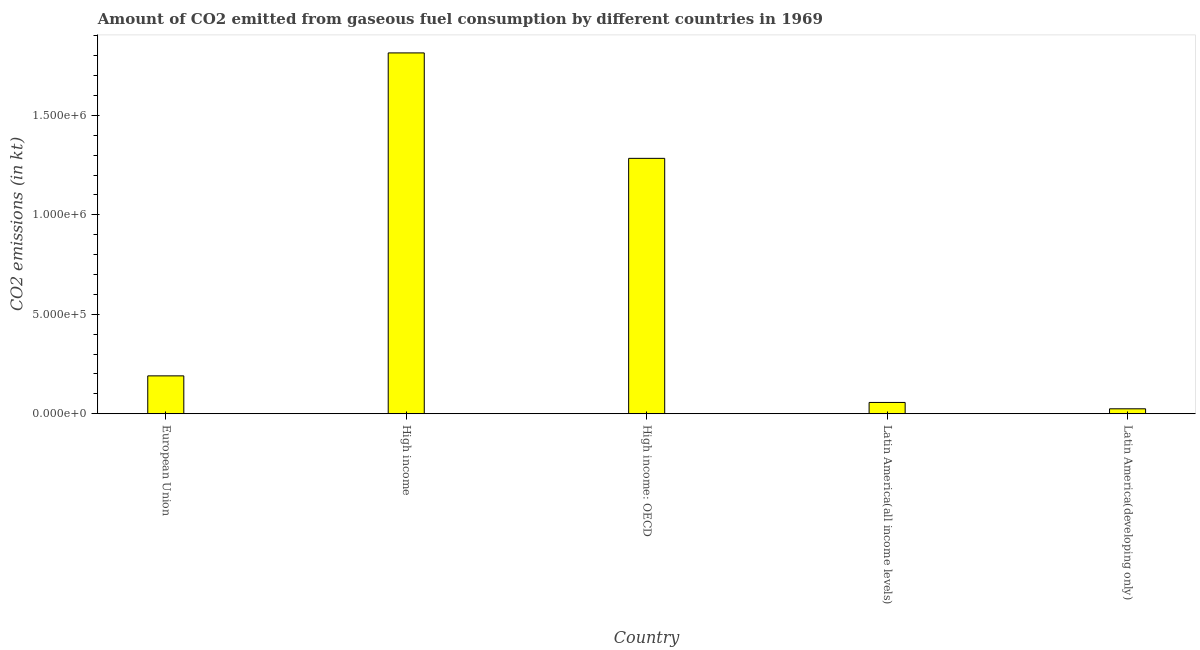What is the title of the graph?
Make the answer very short. Amount of CO2 emitted from gaseous fuel consumption by different countries in 1969. What is the label or title of the Y-axis?
Your response must be concise. CO2 emissions (in kt). What is the co2 emissions from gaseous fuel consumption in Latin America(all income levels)?
Keep it short and to the point. 5.68e+04. Across all countries, what is the maximum co2 emissions from gaseous fuel consumption?
Give a very brief answer. 1.81e+06. Across all countries, what is the minimum co2 emissions from gaseous fuel consumption?
Your response must be concise. 2.48e+04. In which country was the co2 emissions from gaseous fuel consumption maximum?
Ensure brevity in your answer.  High income. In which country was the co2 emissions from gaseous fuel consumption minimum?
Give a very brief answer. Latin America(developing only). What is the sum of the co2 emissions from gaseous fuel consumption?
Provide a short and direct response. 3.37e+06. What is the difference between the co2 emissions from gaseous fuel consumption in Latin America(all income levels) and Latin America(developing only)?
Make the answer very short. 3.20e+04. What is the average co2 emissions from gaseous fuel consumption per country?
Ensure brevity in your answer.  6.74e+05. What is the median co2 emissions from gaseous fuel consumption?
Your answer should be very brief. 1.90e+05. In how many countries, is the co2 emissions from gaseous fuel consumption greater than 1400000 kt?
Your answer should be compact. 1. What is the ratio of the co2 emissions from gaseous fuel consumption in European Union to that in Latin America(developing only)?
Your response must be concise. 7.68. Is the difference between the co2 emissions from gaseous fuel consumption in High income and Latin America(developing only) greater than the difference between any two countries?
Provide a succinct answer. Yes. What is the difference between the highest and the second highest co2 emissions from gaseous fuel consumption?
Make the answer very short. 5.30e+05. Is the sum of the co2 emissions from gaseous fuel consumption in European Union and High income: OECD greater than the maximum co2 emissions from gaseous fuel consumption across all countries?
Make the answer very short. No. What is the difference between the highest and the lowest co2 emissions from gaseous fuel consumption?
Provide a short and direct response. 1.79e+06. In how many countries, is the co2 emissions from gaseous fuel consumption greater than the average co2 emissions from gaseous fuel consumption taken over all countries?
Your answer should be compact. 2. How many bars are there?
Keep it short and to the point. 5. Are all the bars in the graph horizontal?
Your answer should be compact. No. Are the values on the major ticks of Y-axis written in scientific E-notation?
Provide a short and direct response. Yes. What is the CO2 emissions (in kt) in European Union?
Offer a terse response. 1.90e+05. What is the CO2 emissions (in kt) in High income?
Ensure brevity in your answer.  1.81e+06. What is the CO2 emissions (in kt) of High income: OECD?
Provide a short and direct response. 1.28e+06. What is the CO2 emissions (in kt) in Latin America(all income levels)?
Your answer should be compact. 5.68e+04. What is the CO2 emissions (in kt) of Latin America(developing only)?
Make the answer very short. 2.48e+04. What is the difference between the CO2 emissions (in kt) in European Union and High income?
Provide a succinct answer. -1.62e+06. What is the difference between the CO2 emissions (in kt) in European Union and High income: OECD?
Offer a terse response. -1.09e+06. What is the difference between the CO2 emissions (in kt) in European Union and Latin America(all income levels)?
Offer a very short reply. 1.34e+05. What is the difference between the CO2 emissions (in kt) in European Union and Latin America(developing only)?
Your response must be concise. 1.66e+05. What is the difference between the CO2 emissions (in kt) in High income and High income: OECD?
Your answer should be very brief. 5.30e+05. What is the difference between the CO2 emissions (in kt) in High income and Latin America(all income levels)?
Your answer should be very brief. 1.76e+06. What is the difference between the CO2 emissions (in kt) in High income and Latin America(developing only)?
Give a very brief answer. 1.79e+06. What is the difference between the CO2 emissions (in kt) in High income: OECD and Latin America(all income levels)?
Offer a very short reply. 1.23e+06. What is the difference between the CO2 emissions (in kt) in High income: OECD and Latin America(developing only)?
Provide a succinct answer. 1.26e+06. What is the difference between the CO2 emissions (in kt) in Latin America(all income levels) and Latin America(developing only)?
Make the answer very short. 3.20e+04. What is the ratio of the CO2 emissions (in kt) in European Union to that in High income?
Your answer should be compact. 0.1. What is the ratio of the CO2 emissions (in kt) in European Union to that in High income: OECD?
Your response must be concise. 0.15. What is the ratio of the CO2 emissions (in kt) in European Union to that in Latin America(all income levels)?
Your answer should be very brief. 3.35. What is the ratio of the CO2 emissions (in kt) in European Union to that in Latin America(developing only)?
Offer a very short reply. 7.68. What is the ratio of the CO2 emissions (in kt) in High income to that in High income: OECD?
Offer a terse response. 1.41. What is the ratio of the CO2 emissions (in kt) in High income to that in Latin America(all income levels)?
Your answer should be very brief. 31.95. What is the ratio of the CO2 emissions (in kt) in High income to that in Latin America(developing only)?
Provide a succinct answer. 73.14. What is the ratio of the CO2 emissions (in kt) in High income: OECD to that in Latin America(all income levels)?
Offer a terse response. 22.61. What is the ratio of the CO2 emissions (in kt) in High income: OECD to that in Latin America(developing only)?
Your answer should be very brief. 51.77. What is the ratio of the CO2 emissions (in kt) in Latin America(all income levels) to that in Latin America(developing only)?
Give a very brief answer. 2.29. 